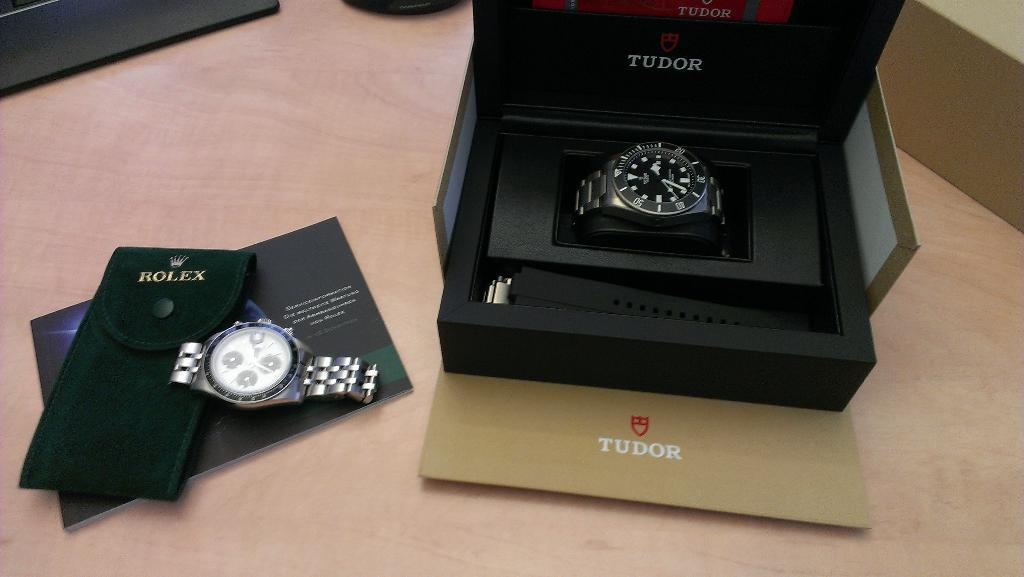<image>
Write a terse but informative summary of the picture. A watch in a black box and the word Tudor visible. 